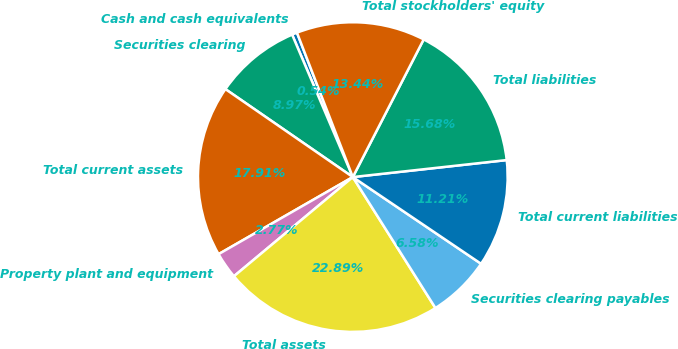Convert chart. <chart><loc_0><loc_0><loc_500><loc_500><pie_chart><fcel>Cash and cash equivalents<fcel>Securities clearing<fcel>Total current assets<fcel>Property plant and equipment<fcel>Total assets<fcel>Securities clearing payables<fcel>Total current liabilities<fcel>Total liabilities<fcel>Total stockholders' equity<nl><fcel>0.54%<fcel>8.97%<fcel>17.91%<fcel>2.77%<fcel>22.89%<fcel>6.58%<fcel>11.21%<fcel>15.68%<fcel>13.44%<nl></chart> 